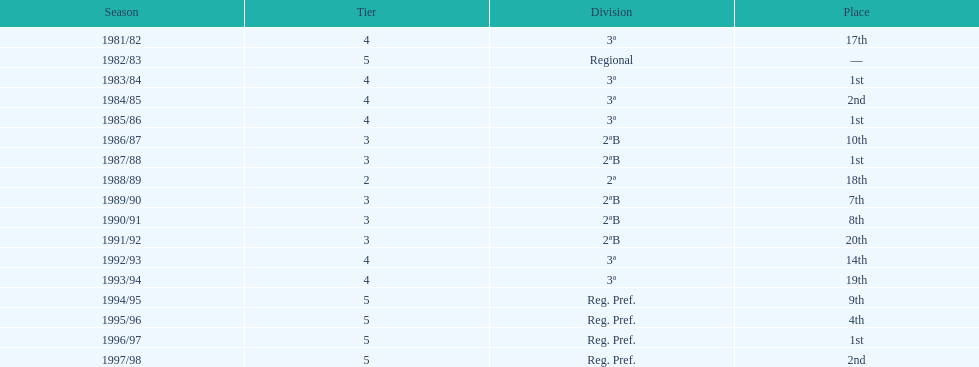Which tier was ud alzira a part of the least? 2. 